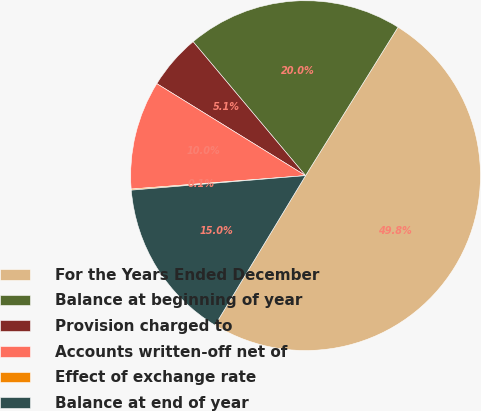<chart> <loc_0><loc_0><loc_500><loc_500><pie_chart><fcel>For the Years Ended December<fcel>Balance at beginning of year<fcel>Provision charged to<fcel>Accounts written-off net of<fcel>Effect of exchange rate<fcel>Balance at end of year<nl><fcel>49.8%<fcel>19.98%<fcel>5.07%<fcel>10.04%<fcel>0.1%<fcel>15.01%<nl></chart> 